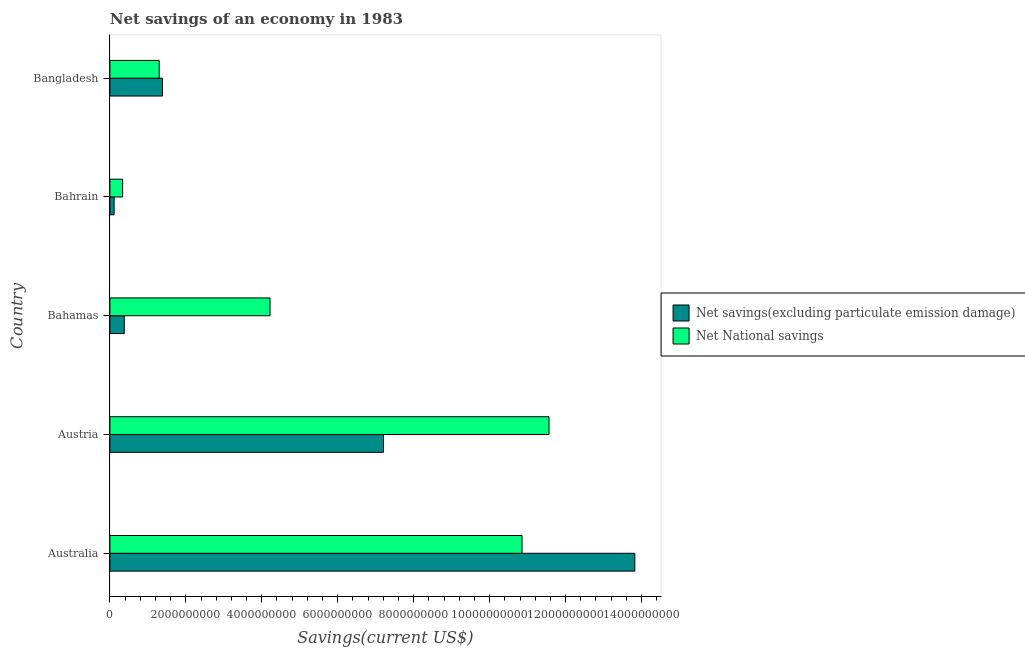How many different coloured bars are there?
Ensure brevity in your answer.  2. Are the number of bars per tick equal to the number of legend labels?
Provide a succinct answer. Yes. Are the number of bars on each tick of the Y-axis equal?
Keep it short and to the point. Yes. How many bars are there on the 1st tick from the top?
Provide a succinct answer. 2. How many bars are there on the 5th tick from the bottom?
Offer a terse response. 2. What is the label of the 1st group of bars from the top?
Your answer should be very brief. Bangladesh. What is the net national savings in Bahrain?
Your answer should be compact. 3.34e+08. Across all countries, what is the maximum net savings(excluding particulate emission damage)?
Offer a terse response. 1.38e+1. Across all countries, what is the minimum net national savings?
Your answer should be very brief. 3.34e+08. In which country was the net national savings minimum?
Your answer should be very brief. Bahrain. What is the total net national savings in the graph?
Your answer should be compact. 2.83e+1. What is the difference between the net national savings in Australia and that in Austria?
Your answer should be very brief. -7.11e+08. What is the difference between the net national savings in Bangladesh and the net savings(excluding particulate emission damage) in Australia?
Provide a short and direct response. -1.25e+1. What is the average net national savings per country?
Keep it short and to the point. 5.65e+09. What is the difference between the net national savings and net savings(excluding particulate emission damage) in Austria?
Keep it short and to the point. 4.36e+09. What is the ratio of the net national savings in Australia to that in Bahrain?
Make the answer very short. 32.45. Is the difference between the net national savings in Australia and Bahrain greater than the difference between the net savings(excluding particulate emission damage) in Australia and Bahrain?
Your answer should be compact. No. What is the difference between the highest and the second highest net savings(excluding particulate emission damage)?
Provide a short and direct response. 6.62e+09. What is the difference between the highest and the lowest net national savings?
Your answer should be very brief. 1.12e+1. What does the 2nd bar from the top in Austria represents?
Your response must be concise. Net savings(excluding particulate emission damage). What does the 2nd bar from the bottom in Bangladesh represents?
Ensure brevity in your answer.  Net National savings. How many countries are there in the graph?
Offer a very short reply. 5. Does the graph contain grids?
Offer a very short reply. No. How are the legend labels stacked?
Make the answer very short. Vertical. What is the title of the graph?
Offer a very short reply. Net savings of an economy in 1983. What is the label or title of the X-axis?
Provide a short and direct response. Savings(current US$). What is the Savings(current US$) in Net savings(excluding particulate emission damage) in Australia?
Keep it short and to the point. 1.38e+1. What is the Savings(current US$) of Net National savings in Australia?
Ensure brevity in your answer.  1.09e+1. What is the Savings(current US$) of Net savings(excluding particulate emission damage) in Austria?
Give a very brief answer. 7.20e+09. What is the Savings(current US$) of Net National savings in Austria?
Your answer should be compact. 1.16e+1. What is the Savings(current US$) of Net savings(excluding particulate emission damage) in Bahamas?
Offer a terse response. 3.79e+08. What is the Savings(current US$) of Net National savings in Bahamas?
Give a very brief answer. 4.22e+09. What is the Savings(current US$) in Net savings(excluding particulate emission damage) in Bahrain?
Offer a very short reply. 1.11e+08. What is the Savings(current US$) of Net National savings in Bahrain?
Provide a short and direct response. 3.34e+08. What is the Savings(current US$) in Net savings(excluding particulate emission damage) in Bangladesh?
Your answer should be very brief. 1.39e+09. What is the Savings(current US$) of Net National savings in Bangladesh?
Keep it short and to the point. 1.30e+09. Across all countries, what is the maximum Savings(current US$) of Net savings(excluding particulate emission damage)?
Provide a short and direct response. 1.38e+1. Across all countries, what is the maximum Savings(current US$) of Net National savings?
Keep it short and to the point. 1.16e+1. Across all countries, what is the minimum Savings(current US$) in Net savings(excluding particulate emission damage)?
Your answer should be compact. 1.11e+08. Across all countries, what is the minimum Savings(current US$) in Net National savings?
Give a very brief answer. 3.34e+08. What is the total Savings(current US$) of Net savings(excluding particulate emission damage) in the graph?
Give a very brief answer. 2.29e+1. What is the total Savings(current US$) in Net National savings in the graph?
Ensure brevity in your answer.  2.83e+1. What is the difference between the Savings(current US$) of Net savings(excluding particulate emission damage) in Australia and that in Austria?
Offer a terse response. 6.62e+09. What is the difference between the Savings(current US$) of Net National savings in Australia and that in Austria?
Your answer should be compact. -7.11e+08. What is the difference between the Savings(current US$) in Net savings(excluding particulate emission damage) in Australia and that in Bahamas?
Your answer should be very brief. 1.34e+1. What is the difference between the Savings(current US$) of Net National savings in Australia and that in Bahamas?
Make the answer very short. 6.64e+09. What is the difference between the Savings(current US$) in Net savings(excluding particulate emission damage) in Australia and that in Bahrain?
Give a very brief answer. 1.37e+1. What is the difference between the Savings(current US$) in Net National savings in Australia and that in Bahrain?
Keep it short and to the point. 1.05e+1. What is the difference between the Savings(current US$) of Net savings(excluding particulate emission damage) in Australia and that in Bangladesh?
Give a very brief answer. 1.24e+1. What is the difference between the Savings(current US$) in Net National savings in Australia and that in Bangladesh?
Provide a short and direct response. 9.55e+09. What is the difference between the Savings(current US$) of Net savings(excluding particulate emission damage) in Austria and that in Bahamas?
Make the answer very short. 6.82e+09. What is the difference between the Savings(current US$) in Net National savings in Austria and that in Bahamas?
Give a very brief answer. 7.35e+09. What is the difference between the Savings(current US$) in Net savings(excluding particulate emission damage) in Austria and that in Bahrain?
Your answer should be compact. 7.09e+09. What is the difference between the Savings(current US$) in Net National savings in Austria and that in Bahrain?
Offer a very short reply. 1.12e+1. What is the difference between the Savings(current US$) of Net savings(excluding particulate emission damage) in Austria and that in Bangladesh?
Your response must be concise. 5.82e+09. What is the difference between the Savings(current US$) in Net National savings in Austria and that in Bangladesh?
Ensure brevity in your answer.  1.03e+1. What is the difference between the Savings(current US$) of Net savings(excluding particulate emission damage) in Bahamas and that in Bahrain?
Your answer should be very brief. 2.67e+08. What is the difference between the Savings(current US$) of Net National savings in Bahamas and that in Bahrain?
Keep it short and to the point. 3.88e+09. What is the difference between the Savings(current US$) of Net savings(excluding particulate emission damage) in Bahamas and that in Bangladesh?
Ensure brevity in your answer.  -1.01e+09. What is the difference between the Savings(current US$) in Net National savings in Bahamas and that in Bangladesh?
Offer a terse response. 2.92e+09. What is the difference between the Savings(current US$) of Net savings(excluding particulate emission damage) in Bahrain and that in Bangladesh?
Ensure brevity in your answer.  -1.27e+09. What is the difference between the Savings(current US$) in Net National savings in Bahrain and that in Bangladesh?
Make the answer very short. -9.64e+08. What is the difference between the Savings(current US$) of Net savings(excluding particulate emission damage) in Australia and the Savings(current US$) of Net National savings in Austria?
Give a very brief answer. 2.26e+09. What is the difference between the Savings(current US$) of Net savings(excluding particulate emission damage) in Australia and the Savings(current US$) of Net National savings in Bahamas?
Offer a very short reply. 9.61e+09. What is the difference between the Savings(current US$) in Net savings(excluding particulate emission damage) in Australia and the Savings(current US$) in Net National savings in Bahrain?
Your response must be concise. 1.35e+1. What is the difference between the Savings(current US$) in Net savings(excluding particulate emission damage) in Australia and the Savings(current US$) in Net National savings in Bangladesh?
Provide a succinct answer. 1.25e+1. What is the difference between the Savings(current US$) in Net savings(excluding particulate emission damage) in Austria and the Savings(current US$) in Net National savings in Bahamas?
Offer a terse response. 2.99e+09. What is the difference between the Savings(current US$) in Net savings(excluding particulate emission damage) in Austria and the Savings(current US$) in Net National savings in Bahrain?
Provide a short and direct response. 6.87e+09. What is the difference between the Savings(current US$) in Net savings(excluding particulate emission damage) in Austria and the Savings(current US$) in Net National savings in Bangladesh?
Your answer should be very brief. 5.91e+09. What is the difference between the Savings(current US$) in Net savings(excluding particulate emission damage) in Bahamas and the Savings(current US$) in Net National savings in Bahrain?
Your answer should be very brief. 4.42e+07. What is the difference between the Savings(current US$) in Net savings(excluding particulate emission damage) in Bahamas and the Savings(current US$) in Net National savings in Bangladesh?
Offer a very short reply. -9.20e+08. What is the difference between the Savings(current US$) of Net savings(excluding particulate emission damage) in Bahrain and the Savings(current US$) of Net National savings in Bangladesh?
Your response must be concise. -1.19e+09. What is the average Savings(current US$) of Net savings(excluding particulate emission damage) per country?
Offer a terse response. 4.58e+09. What is the average Savings(current US$) in Net National savings per country?
Keep it short and to the point. 5.65e+09. What is the difference between the Savings(current US$) in Net savings(excluding particulate emission damage) and Savings(current US$) in Net National savings in Australia?
Offer a very short reply. 2.97e+09. What is the difference between the Savings(current US$) in Net savings(excluding particulate emission damage) and Savings(current US$) in Net National savings in Austria?
Ensure brevity in your answer.  -4.36e+09. What is the difference between the Savings(current US$) in Net savings(excluding particulate emission damage) and Savings(current US$) in Net National savings in Bahamas?
Ensure brevity in your answer.  -3.84e+09. What is the difference between the Savings(current US$) in Net savings(excluding particulate emission damage) and Savings(current US$) in Net National savings in Bahrain?
Your response must be concise. -2.23e+08. What is the difference between the Savings(current US$) in Net savings(excluding particulate emission damage) and Savings(current US$) in Net National savings in Bangladesh?
Your answer should be compact. 8.69e+07. What is the ratio of the Savings(current US$) in Net savings(excluding particulate emission damage) in Australia to that in Austria?
Your response must be concise. 1.92. What is the ratio of the Savings(current US$) of Net National savings in Australia to that in Austria?
Ensure brevity in your answer.  0.94. What is the ratio of the Savings(current US$) of Net savings(excluding particulate emission damage) in Australia to that in Bahamas?
Make the answer very short. 36.51. What is the ratio of the Savings(current US$) of Net National savings in Australia to that in Bahamas?
Make the answer very short. 2.57. What is the ratio of the Savings(current US$) of Net savings(excluding particulate emission damage) in Australia to that in Bahrain?
Ensure brevity in your answer.  124.02. What is the ratio of the Savings(current US$) in Net National savings in Australia to that in Bahrain?
Offer a very short reply. 32.45. What is the ratio of the Savings(current US$) in Net savings(excluding particulate emission damage) in Australia to that in Bangladesh?
Your answer should be compact. 9.98. What is the ratio of the Savings(current US$) in Net National savings in Australia to that in Bangladesh?
Your answer should be very brief. 8.36. What is the ratio of the Savings(current US$) in Net savings(excluding particulate emission damage) in Austria to that in Bahamas?
Give a very brief answer. 19.03. What is the ratio of the Savings(current US$) in Net National savings in Austria to that in Bahamas?
Provide a short and direct response. 2.74. What is the ratio of the Savings(current US$) of Net savings(excluding particulate emission damage) in Austria to that in Bahrain?
Your answer should be compact. 64.63. What is the ratio of the Savings(current US$) of Net National savings in Austria to that in Bahrain?
Provide a succinct answer. 34.57. What is the ratio of the Savings(current US$) in Net savings(excluding particulate emission damage) in Austria to that in Bangladesh?
Ensure brevity in your answer.  5.2. What is the ratio of the Savings(current US$) of Net National savings in Austria to that in Bangladesh?
Ensure brevity in your answer.  8.91. What is the ratio of the Savings(current US$) of Net savings(excluding particulate emission damage) in Bahamas to that in Bahrain?
Provide a short and direct response. 3.4. What is the ratio of the Savings(current US$) in Net National savings in Bahamas to that in Bahrain?
Ensure brevity in your answer.  12.61. What is the ratio of the Savings(current US$) in Net savings(excluding particulate emission damage) in Bahamas to that in Bangladesh?
Make the answer very short. 0.27. What is the ratio of the Savings(current US$) in Net National savings in Bahamas to that in Bangladesh?
Your answer should be compact. 3.25. What is the ratio of the Savings(current US$) of Net savings(excluding particulate emission damage) in Bahrain to that in Bangladesh?
Give a very brief answer. 0.08. What is the ratio of the Savings(current US$) in Net National savings in Bahrain to that in Bangladesh?
Provide a short and direct response. 0.26. What is the difference between the highest and the second highest Savings(current US$) in Net savings(excluding particulate emission damage)?
Keep it short and to the point. 6.62e+09. What is the difference between the highest and the second highest Savings(current US$) of Net National savings?
Provide a short and direct response. 7.11e+08. What is the difference between the highest and the lowest Savings(current US$) in Net savings(excluding particulate emission damage)?
Give a very brief answer. 1.37e+1. What is the difference between the highest and the lowest Savings(current US$) in Net National savings?
Give a very brief answer. 1.12e+1. 